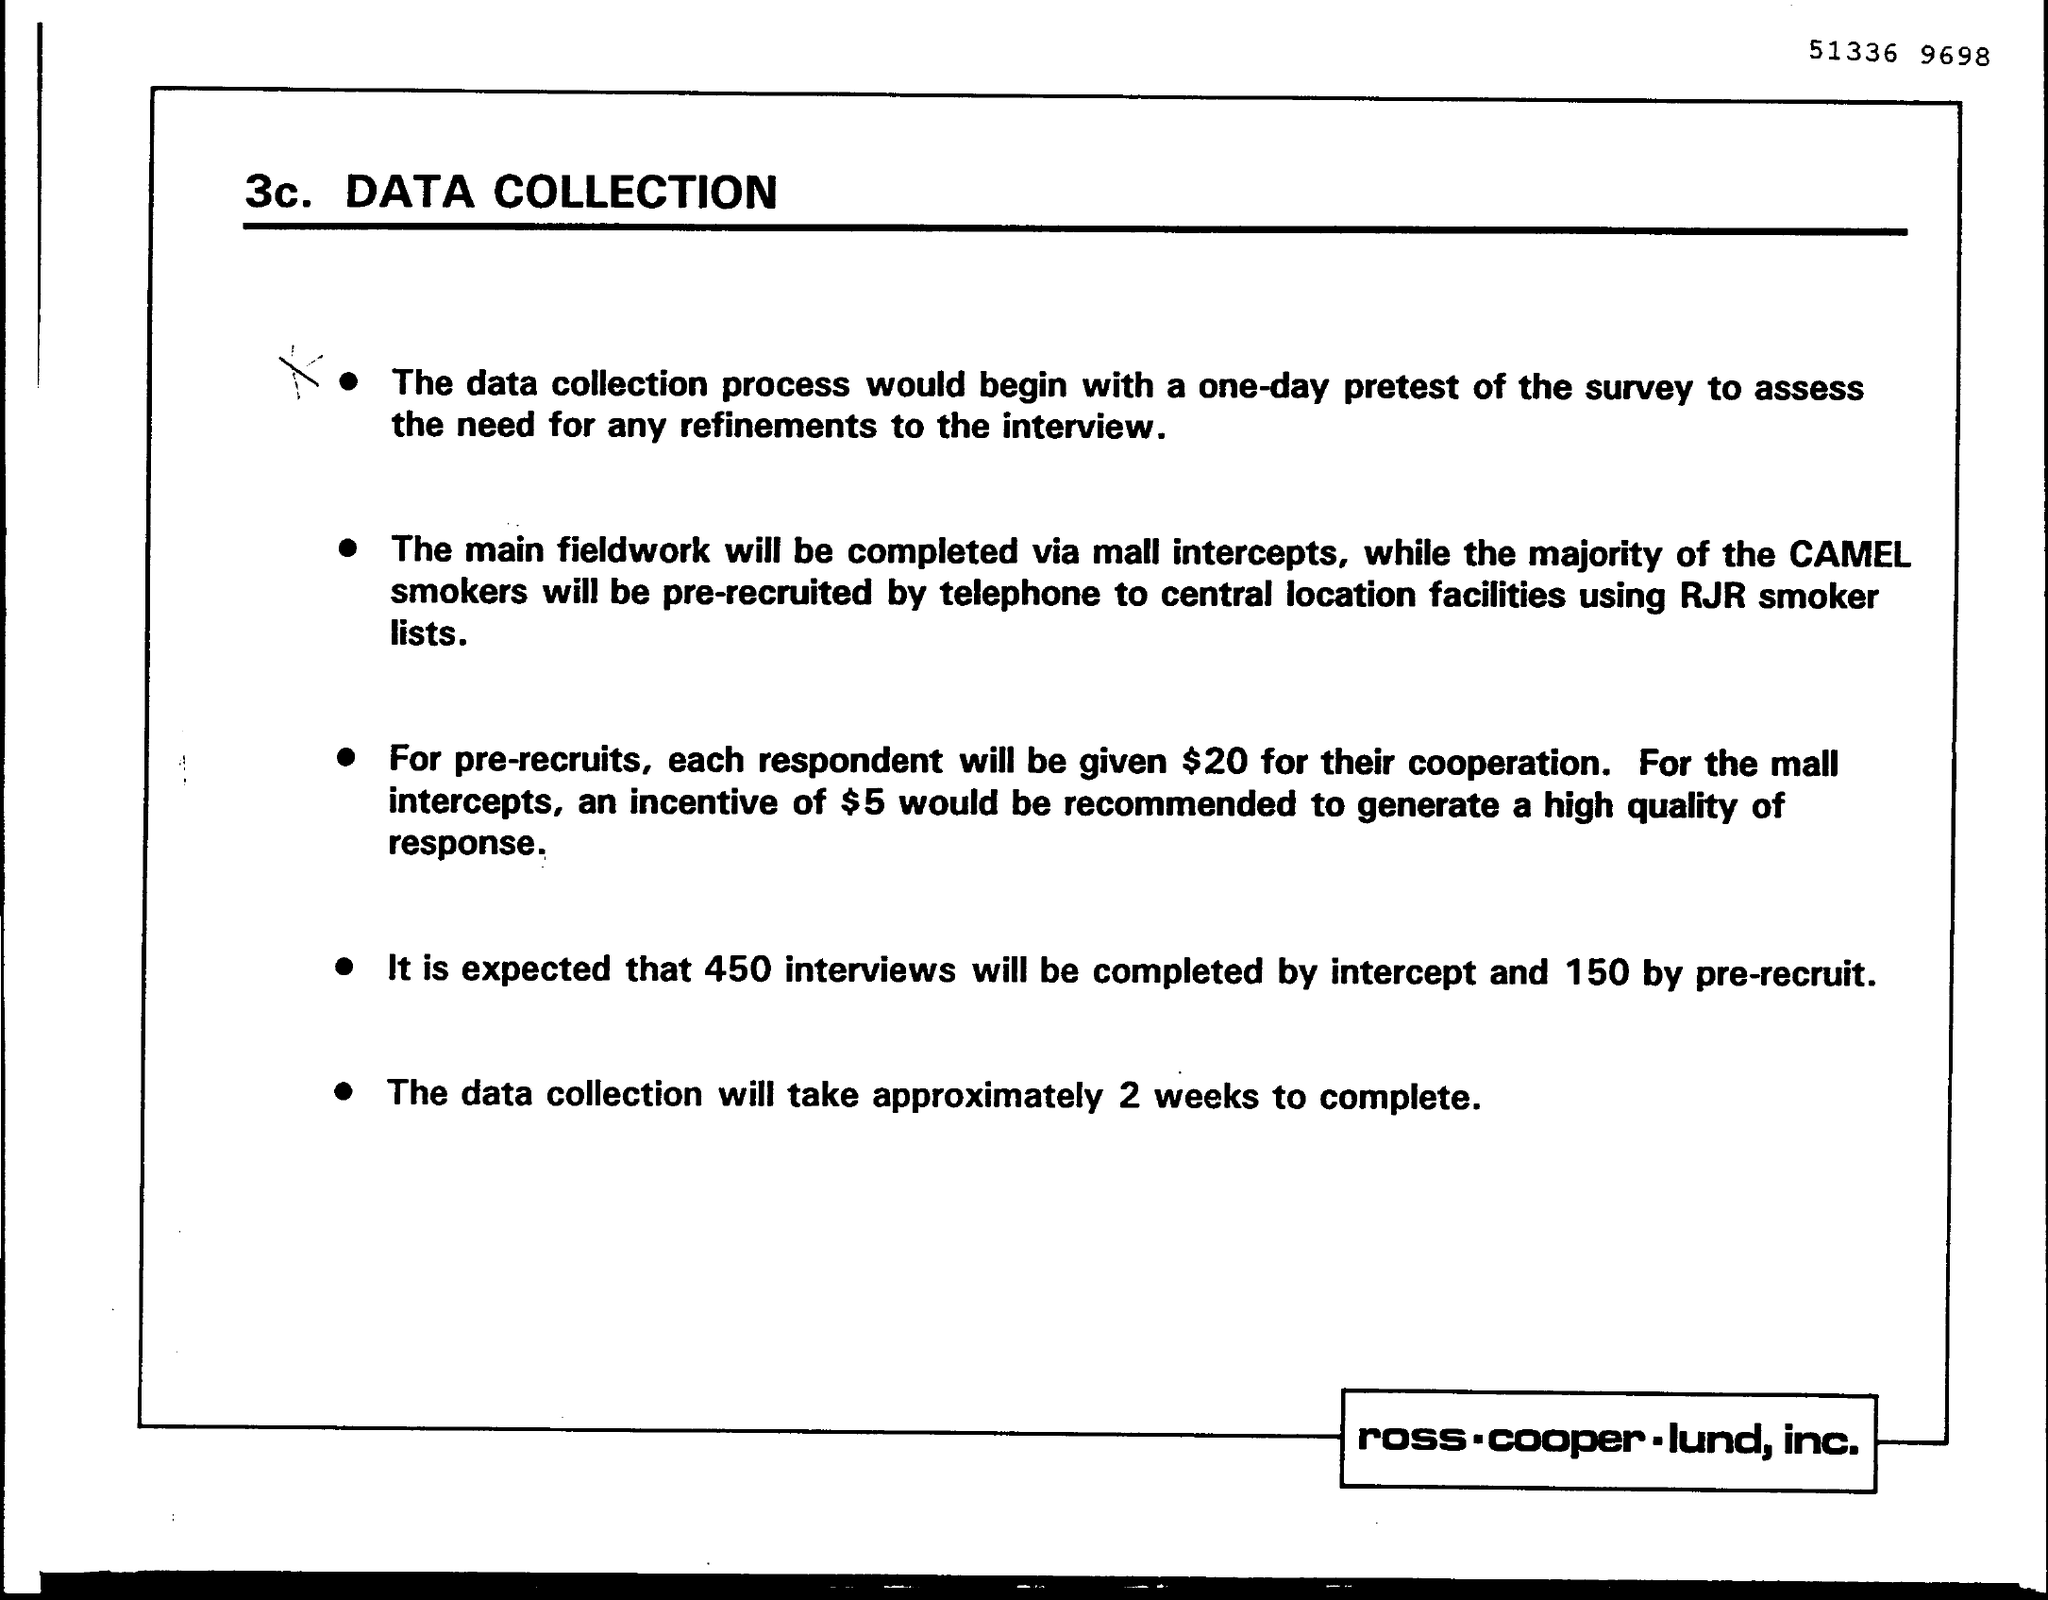Point out several critical features in this image. It is expected that a total of 450 interviews will be completed. 